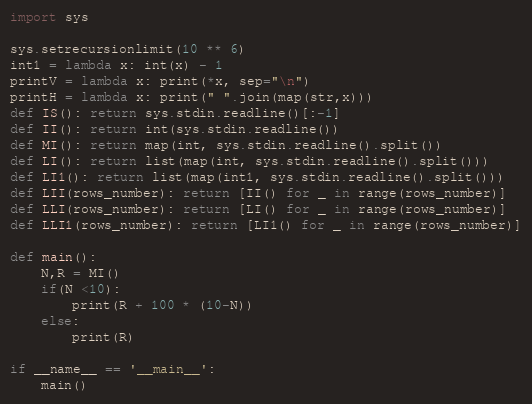<code> <loc_0><loc_0><loc_500><loc_500><_Python_>import sys

sys.setrecursionlimit(10 ** 6)
int1 = lambda x: int(x) - 1
printV = lambda x: print(*x, sep="\n")
printH = lambda x: print(" ".join(map(str,x)))
def IS(): return sys.stdin.readline()[:-1]
def II(): return int(sys.stdin.readline())
def MI(): return map(int, sys.stdin.readline().split())
def LI(): return list(map(int, sys.stdin.readline().split()))
def LI1(): return list(map(int1, sys.stdin.readline().split()))
def LII(rows_number): return [II() for _ in range(rows_number)]
def LLI(rows_number): return [LI() for _ in range(rows_number)]
def LLI1(rows_number): return [LI1() for _ in range(rows_number)]

def main():
	N,R = MI()
	if(N <10):
		print(R + 100 * (10-N))
	else:
		print(R)

if __name__ == '__main__':
	main()</code> 